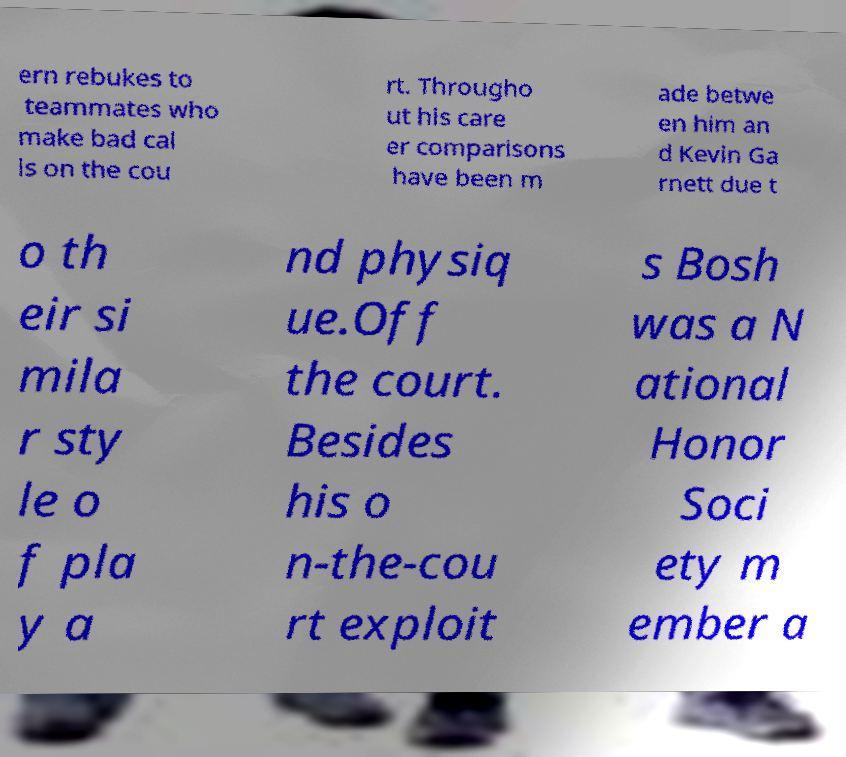Could you extract and type out the text from this image? ern rebukes to teammates who make bad cal ls on the cou rt. Througho ut his care er comparisons have been m ade betwe en him an d Kevin Ga rnett due t o th eir si mila r sty le o f pla y a nd physiq ue.Off the court. Besides his o n-the-cou rt exploit s Bosh was a N ational Honor Soci ety m ember a 